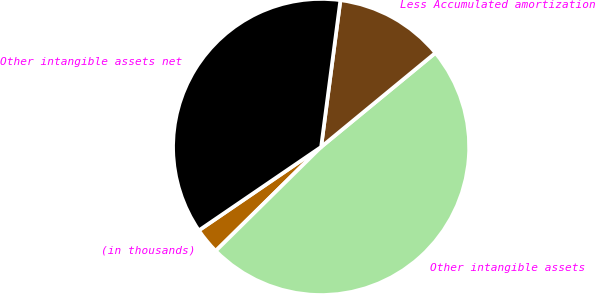<chart> <loc_0><loc_0><loc_500><loc_500><pie_chart><fcel>(in thousands)<fcel>Other intangible assets<fcel>Less Accumulated amortization<fcel>Other intangible assets net<nl><fcel>2.86%<fcel>48.57%<fcel>11.96%<fcel>36.61%<nl></chart> 